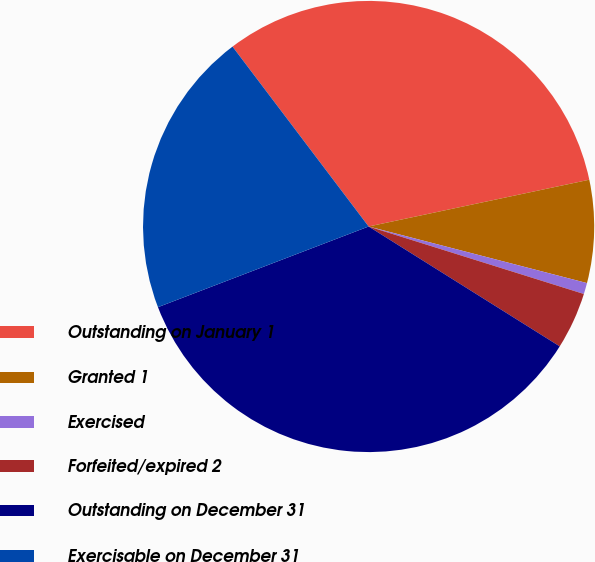<chart> <loc_0><loc_0><loc_500><loc_500><pie_chart><fcel>Outstanding on January 1<fcel>Granted 1<fcel>Exercised<fcel>Forfeited/expired 2<fcel>Outstanding on December 31<fcel>Exercisable on December 31<nl><fcel>31.98%<fcel>7.36%<fcel>0.8%<fcel>4.08%<fcel>35.26%<fcel>20.51%<nl></chart> 